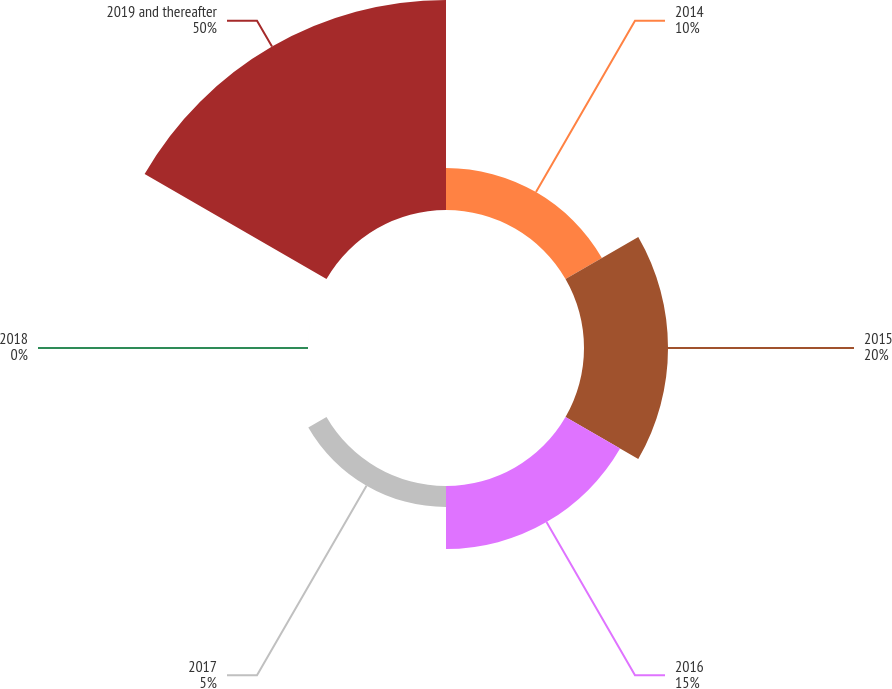Convert chart to OTSL. <chart><loc_0><loc_0><loc_500><loc_500><pie_chart><fcel>2014<fcel>2015<fcel>2016<fcel>2017<fcel>2018<fcel>2019 and thereafter<nl><fcel>10.0%<fcel>20.0%<fcel>15.0%<fcel>5.0%<fcel>0.0%<fcel>49.99%<nl></chart> 